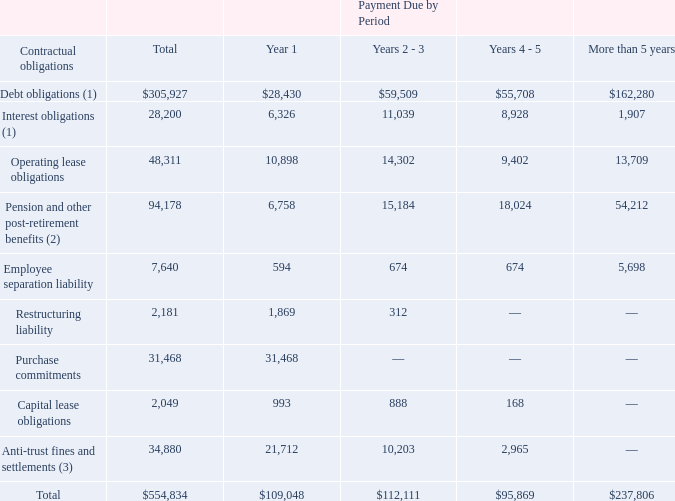Commitments
At March 31, 2019, we had contractual obligations in the form of non-cancellable operating leases and debt, including interest payments (see Note 3, “Debt” and Note 15, “Commitments and Contingencies” to our consolidated financial statements), European social security, pension benefits, other post-retirement benefits, inventory purchase obligations, fixed asset purchase obligations, acquisition related obligations, and construction obligations as follows (amounts in thousands):
(1) Refer to Note 3, “Debt” for additional information. Repayment of the Customer Capacity Agreements assumes the customers purchase products in a quantity sufficient to require the maximum permitted debt repayment amount per quarter.
(2) Reflects expected benefit payments through fiscal year 2029.
(3) In addition to amounts reflected in the table, an additional $2.9 million has been recorded in the line item "Accrued expenses," for which the timing of payment has not been determined.
What did Pension and other post-retirement benefits reflect? Expected benefit payments through fiscal year 2029. What were the total debt obligations?
Answer scale should be: thousand. 305,927. What were the interest obligations that had payments due more than 5 years?
Answer scale should be: thousand. 1,907. What was the difference in the total between Employee separation liability and Restructuring liability?
Answer scale should be: thousand. 7,640-2,181
Answer: 5459. What was the difference between the payments due by Year 1 between Interest obligations and operating lease obligations?
Answer scale should be: thousand. 10,898-6,326
Answer: 4572. What were the total debt obligations as a percentage of the total contractual obligations?
Answer scale should be: percent. 305,927/554,834
Answer: 55.14. 